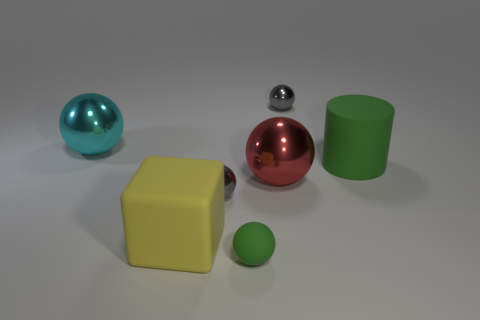Subtract all gray balls. How many were subtracted if there are1gray balls left? 1 Subtract all cyan spheres. How many spheres are left? 4 Subtract all spheres. How many objects are left? 2 Subtract all green balls. How many balls are left? 4 Subtract 1 green balls. How many objects are left? 6 Subtract 1 spheres. How many spheres are left? 4 Subtract all purple cylinders. Subtract all yellow blocks. How many cylinders are left? 1 Subtract all purple cylinders. How many red cubes are left? 0 Subtract all small green things. Subtract all shiny objects. How many objects are left? 2 Add 1 small things. How many small things are left? 4 